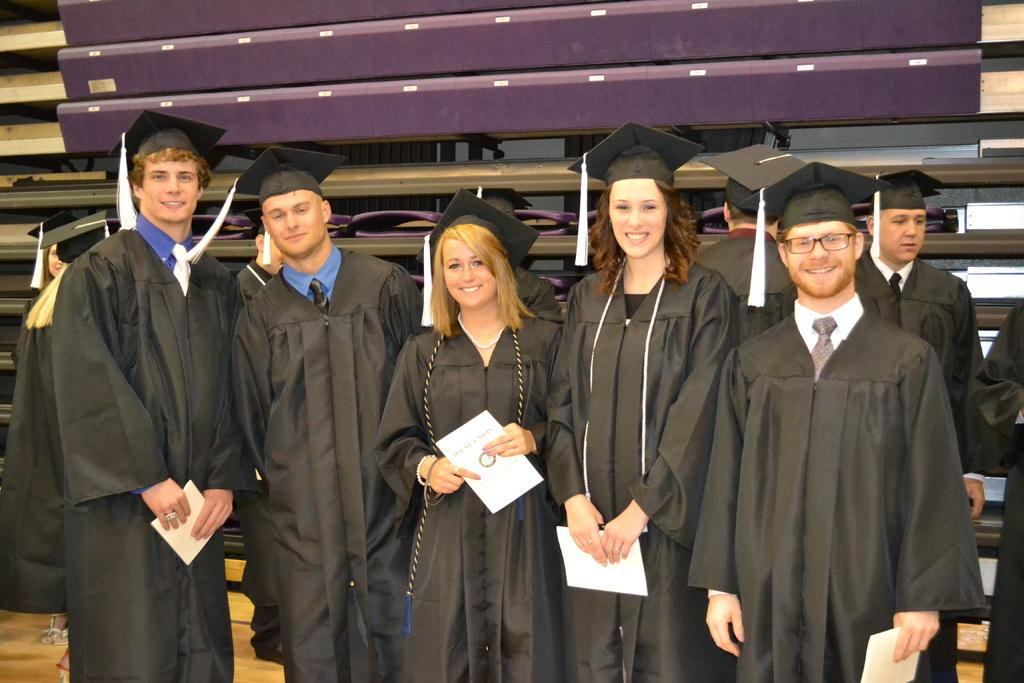What can be observed about the people in the image? There are groups of people in the image, and they are wearing academic dresses. What might the people be holding in their hands? Some people are holding papers in their hands. What can be seen behind the people in the image? There are objects visible behind the people. What type of discussion is taking place in the image? There is no indication of a discussion taking place in the image. Can you see a stove in the image? There is no stove present in the image. 